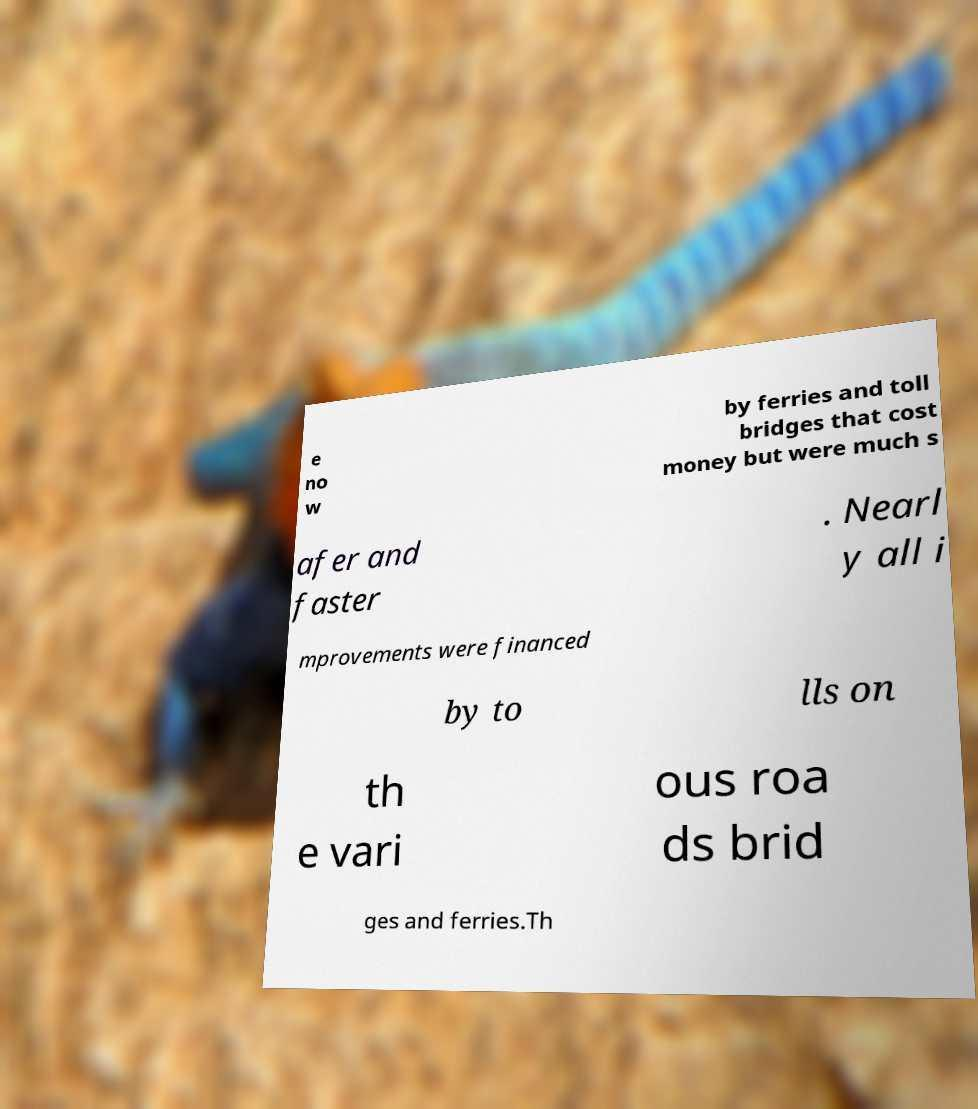Please identify and transcribe the text found in this image. e no w by ferries and toll bridges that cost money but were much s afer and faster . Nearl y all i mprovements were financed by to lls on th e vari ous roa ds brid ges and ferries.Th 